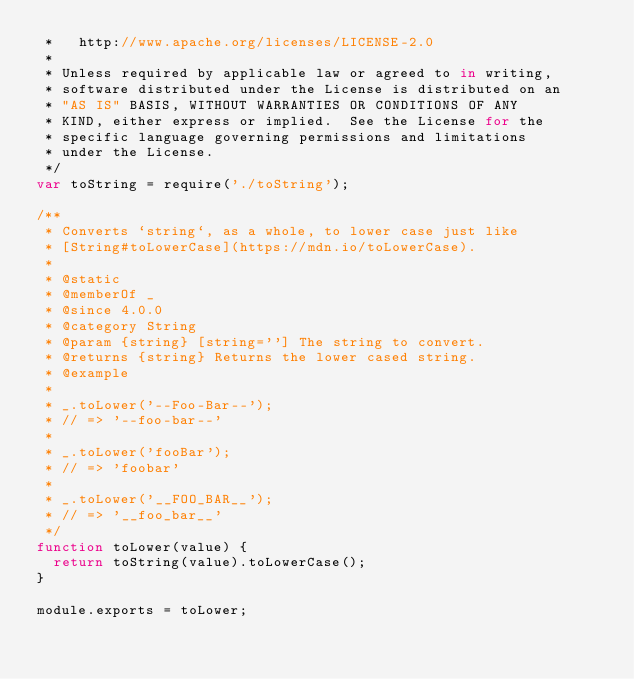<code> <loc_0><loc_0><loc_500><loc_500><_JavaScript_> *   http://www.apache.org/licenses/LICENSE-2.0
 *
 * Unless required by applicable law or agreed to in writing,
 * software distributed under the License is distributed on an
 * "AS IS" BASIS, WITHOUT WARRANTIES OR CONDITIONS OF ANY
 * KIND, either express or implied.  See the License for the
 * specific language governing permissions and limitations
 * under the License.
 */
var toString = require('./toString');

/**
 * Converts `string`, as a whole, to lower case just like
 * [String#toLowerCase](https://mdn.io/toLowerCase).
 *
 * @static
 * @memberOf _
 * @since 4.0.0
 * @category String
 * @param {string} [string=''] The string to convert.
 * @returns {string} Returns the lower cased string.
 * @example
 *
 * _.toLower('--Foo-Bar--');
 * // => '--foo-bar--'
 *
 * _.toLower('fooBar');
 * // => 'foobar'
 *
 * _.toLower('__FOO_BAR__');
 * // => '__foo_bar__'
 */
function toLower(value) {
  return toString(value).toLowerCase();
}

module.exports = toLower;
</code> 